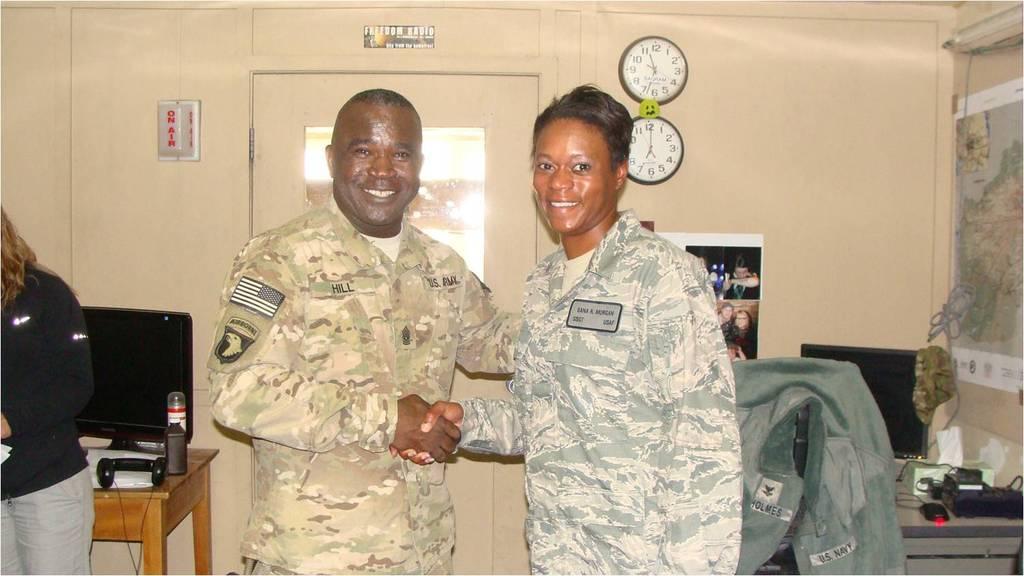In one or two sentences, can you explain what this image depicts? This picture is clicked inside the room. In front of the picture, we see two men are standing. They are shaking their hands and both of them are smiling. On the right side, we see a green jacket. Behind that, we see a table on which monitor, mouse and landline phone are placed. Behind that, we see a wall on which posters and blocks are placed. Beside that, we see a door on which a poster is placed. On the left side, we see a woman in black T-shirt is standing. Behind that, we see a table on which monitor, water bottle and papers are placed. 